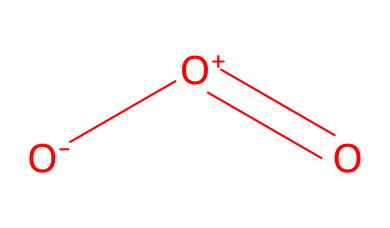What is the name of this chemical? The SMILES representation corresponds to a molecule with three oxygen atoms, which is commonly known as ozone.
Answer: ozone How many oxygen atoms are present in this molecule? The SMILES notation includes three oxygen atoms, indicated by the 'O' characters.
Answer: three What type of structure does this chemical have? The presence of a double bond between two oxygen atoms and a single bond to another oxygen atom indicates a bent molecular structure typical of ozone.
Answer: bent What charge does the overall molecule have? The SMILES representation shows a negative charge on one oxygen and a positive charge on another, resulting in a neutral overall charge for the ozone molecule.
Answer: neutral Which functional role does this chemical play in water purification? Ozone is used primarily as an oxidizing agent, helping in the disinfection and removal of contaminants in water purification processes.
Answer: oxidizing agent How does the molecular composition affect the ozone's properties? The arrangement and bonding of the three oxygen atoms create a reactive molecule that can effectively break down pollutants, due to its instability and high oxidation potential.
Answer: reactivity What is a key application of ozone in air purification? Ozone is commonly used for its ability to deodorize and remove harmful microorganisms in air treatment systems.
Answer: deodorization 